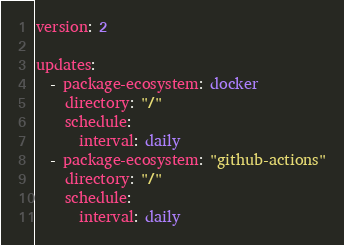<code> <loc_0><loc_0><loc_500><loc_500><_YAML_>version: 2

updates:
  - package-ecosystem: docker
    directory: "/"
    schedule:
      interval: daily
  - package-ecosystem: "github-actions"
    directory: "/"
    schedule:
      interval: daily
</code> 